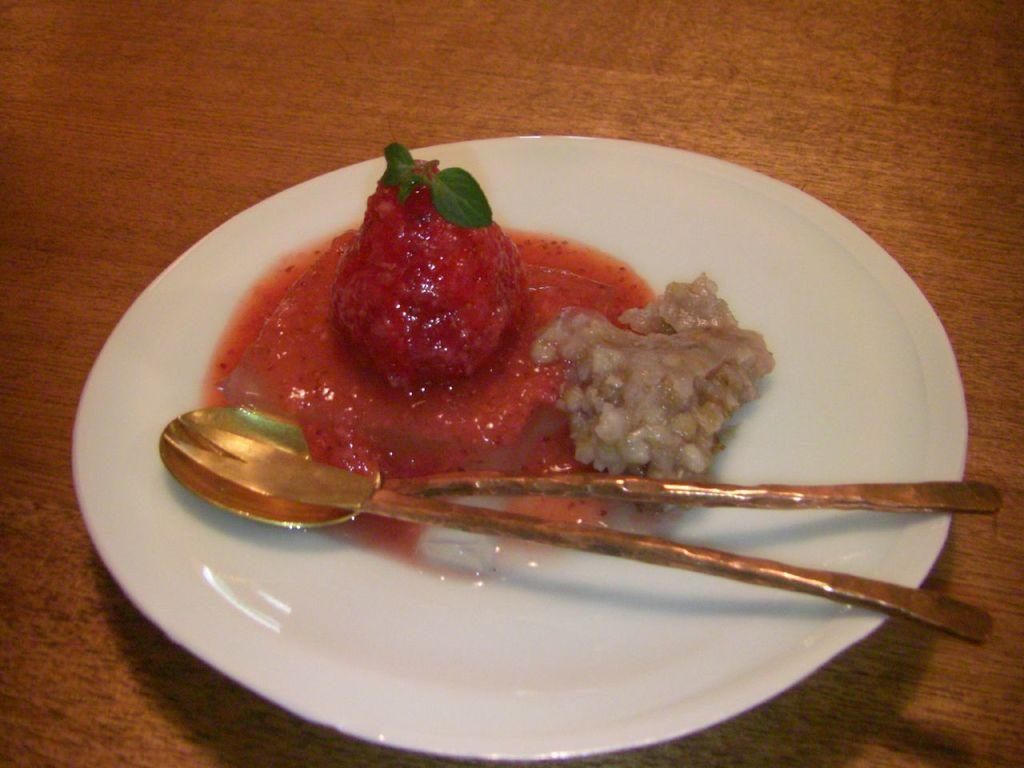What type of food is present in the image? The food contains strawberry, leaves, and cream in the image. How is the food arranged in the image? The food is in a plate. What utensils are present with the food in the image? There is a spoon and a fork in the plate. Where is the plate with the food located? The plate is placed on a table. How many fingers are touching the food in the image? There are no fingers touching the food in the image. What type of furniture is present in the image? The image only shows a plate with food, utensils, and a table, but it does not provide enough information to determine the type of furniture. 